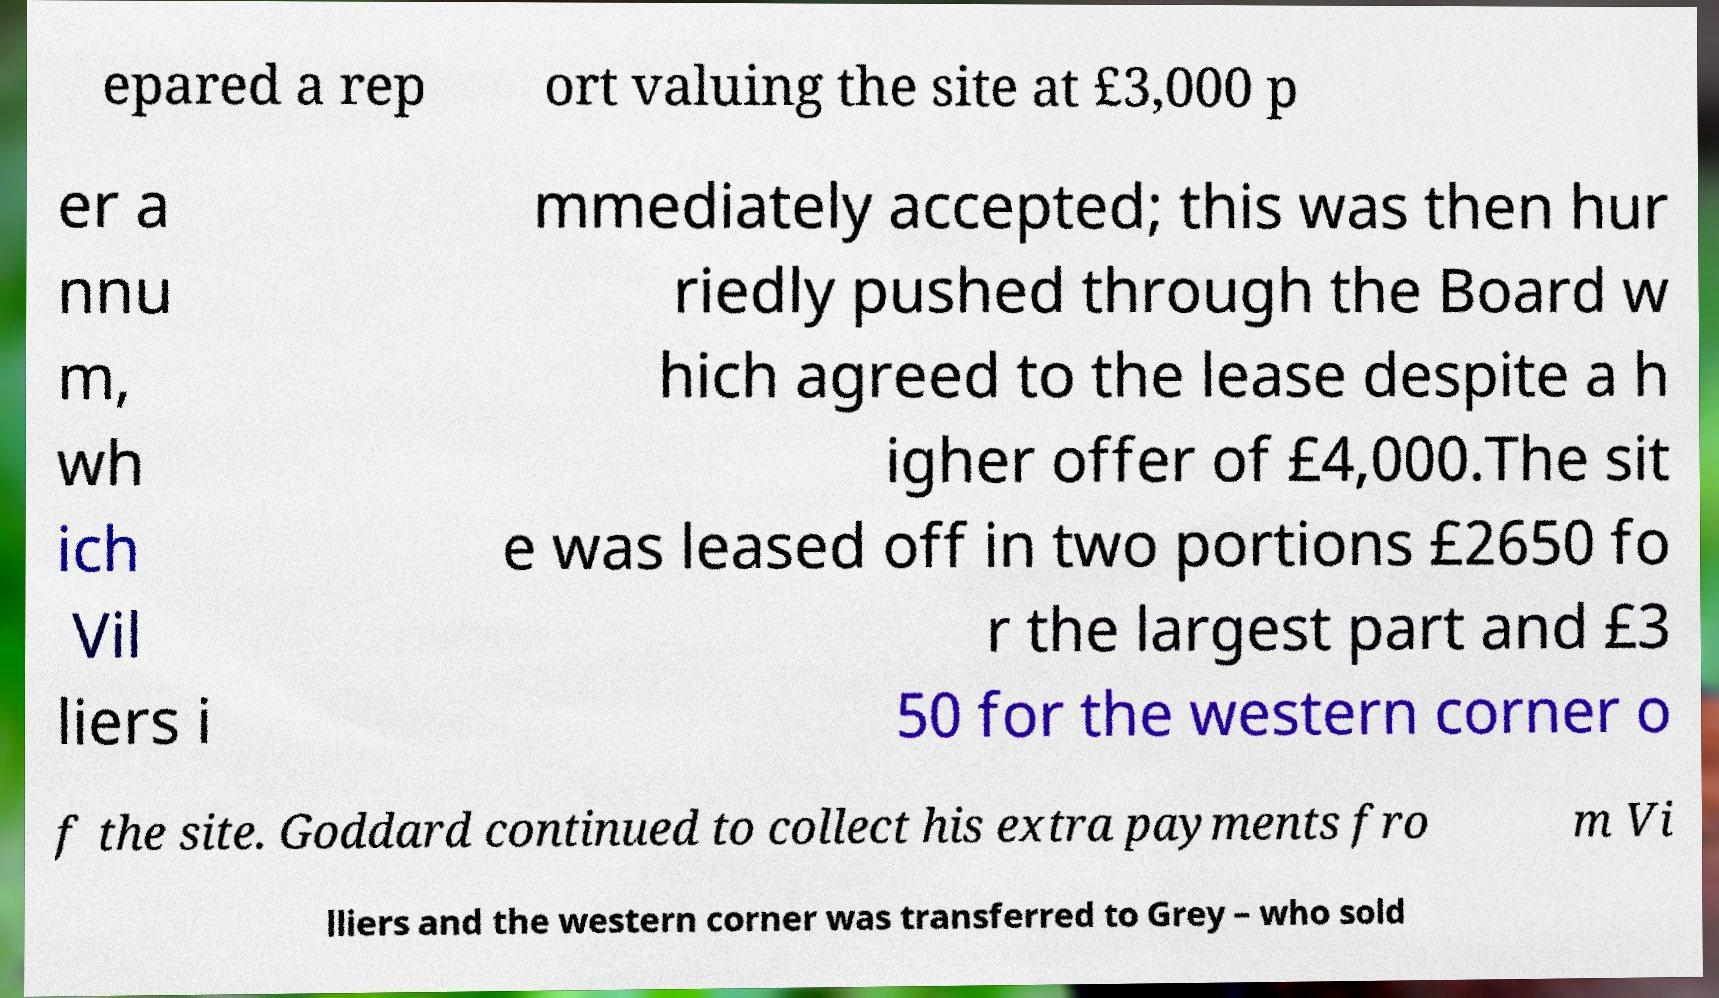For documentation purposes, I need the text within this image transcribed. Could you provide that? epared a rep ort valuing the site at £3,000 p er a nnu m, wh ich Vil liers i mmediately accepted; this was then hur riedly pushed through the Board w hich agreed to the lease despite a h igher offer of £4,000.The sit e was leased off in two portions £2650 fo r the largest part and £3 50 for the western corner o f the site. Goddard continued to collect his extra payments fro m Vi lliers and the western corner was transferred to Grey – who sold 